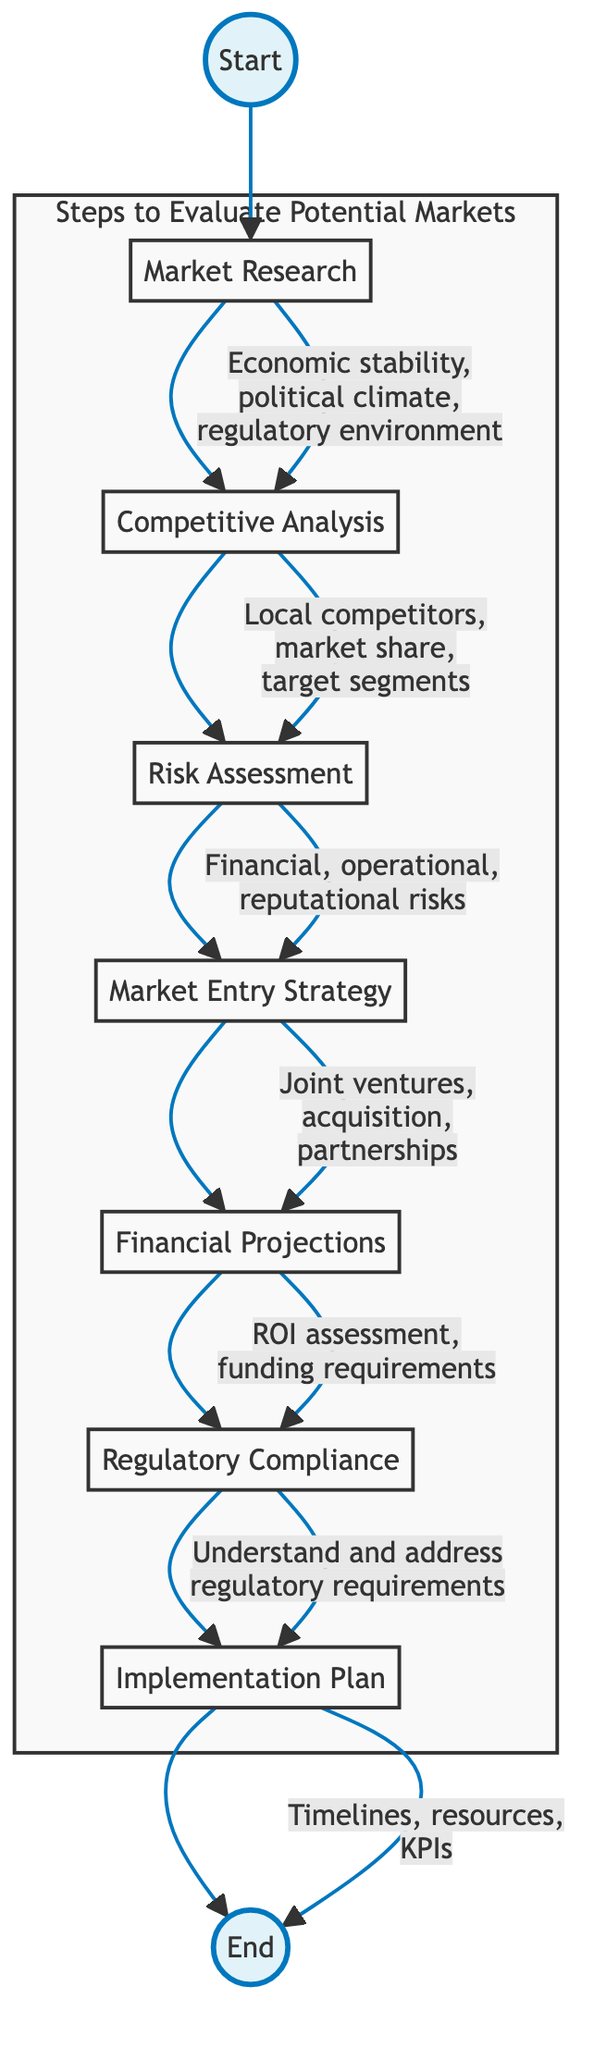What is the first step in the diagram? The first step in the sequence is labeled "Market Research." It is the starting point of the flow chart, and from there, it connects to the next step.
Answer: Market Research How many total steps are represented in the flowchart? The flowchart contains a total of seven steps, which each represent a distinct phase in evaluating potential markets.
Answer: 7 What follows Competitive Analysis in the flowchart? After "Competitive Analysis," the next step in the sequence is "Risk Assessment," which focuses on evaluating various risks related to market entry.
Answer: Risk Assessment Which step addresses the regulatory requirements? The step that addresses regulatory requirements is "Regulatory Compliance." This ensures an understanding of the regulations in the target market before proceeding.
Answer: Regulatory Compliance What potential modes of entry are mentioned in the Market Entry Strategy step? The "Market Entry Strategy" step mentions potential modes of entry, including joint ventures, acquisitions, and partnerships, as strategies for entering a new market.
Answer: Joint ventures, acquisition, partnerships Which stage requires understanding local competitors? The stage that requires understanding local competitors is "Competitive Analysis," where analysis of local market players and their shares is performed.
Answer: Competitive Analysis In which step are financial projections created? Financial projections are created in the "Financial Projections" step, where estimates of return on investment and funding needs are evaluated before entry.
Answer: Financial Projections What is the last step in the evaluation process? The last step in the evaluation process is "Implementation Plan," which involves developing a detailed plan for entering the market with allocated resources and timelines.
Answer: Implementation Plan What type of risks are evaluated in the Risk Assessment step? The "Risk Assessment" step evaluates financial, operational, and reputational risks associated with market entry, ensuring a comprehensive understanding of potential pitfalls.
Answer: Financial, operational, reputational risks 